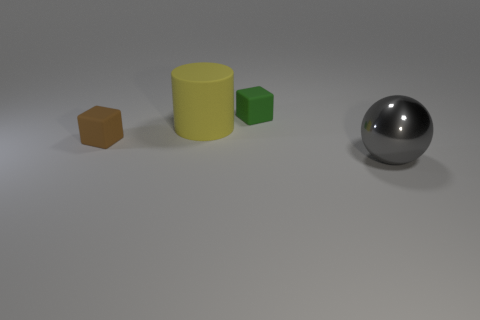How many other things are made of the same material as the gray ball?
Provide a succinct answer. 0. What material is the other thing that is the same shape as the green rubber thing?
Provide a succinct answer. Rubber. There is a large gray metallic object; is its shape the same as the tiny thing that is in front of the large yellow rubber object?
Your response must be concise. No. There is a thing that is both in front of the cylinder and on the left side of the green block; what is its color?
Make the answer very short. Brown. Are there any large matte cylinders?
Your answer should be very brief. Yes. Are there the same number of big rubber things that are to the right of the gray ball and large yellow shiny objects?
Offer a very short reply. Yes. How many other objects are the same shape as the small brown thing?
Provide a short and direct response. 1. There is a gray shiny object; what shape is it?
Provide a succinct answer. Sphere. Are the small green block and the large cylinder made of the same material?
Your response must be concise. Yes. Are there the same number of large yellow objects that are in front of the tiny brown rubber thing and big gray objects that are in front of the big gray sphere?
Make the answer very short. Yes. 